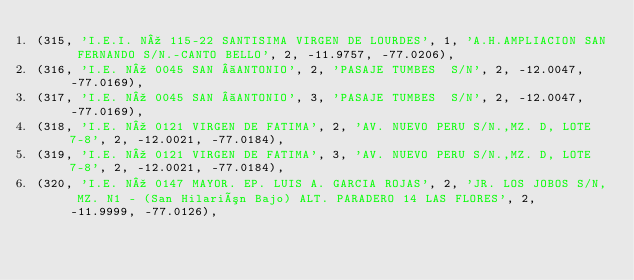Convert code to text. <code><loc_0><loc_0><loc_500><loc_500><_SQL_>(315, 'I.E.I. Nº 115-22 SANTISIMA VIRGEN DE LOURDES', 1, 'A.H.AMPLIACION SAN FERNANDO S/N.-CANTO BELLO', 2, -11.9757, -77.0206),
(316, 'I.E. Nº 0045 SAN  ANTONIO', 2, 'PASAJE TUMBES  S/N', 2, -12.0047, -77.0169),
(317, 'I.E. Nº 0045 SAN  ANTONIO', 3, 'PASAJE TUMBES  S/N', 2, -12.0047, -77.0169),
(318, 'I.E. Nº 0121 VIRGEN DE FATIMA', 2, 'AV. NUEVO PERU S/N.,MZ. D, LOTE 7-8', 2, -12.0021, -77.0184),
(319, 'I.E. Nº 0121 VIRGEN DE FATIMA', 3, 'AV. NUEVO PERU S/N.,MZ. D, LOTE 7-8', 2, -12.0021, -77.0184),
(320, 'I.E. Nº 0147 MAYOR. EP. LUIS A. GARCIA ROJAS', 2, 'JR. LOS JOBOS S/N, MZ. N1 - (San Hilarión Bajo) ALT. PARADERO 14 LAS FLORES', 2, -11.9999, -77.0126),</code> 